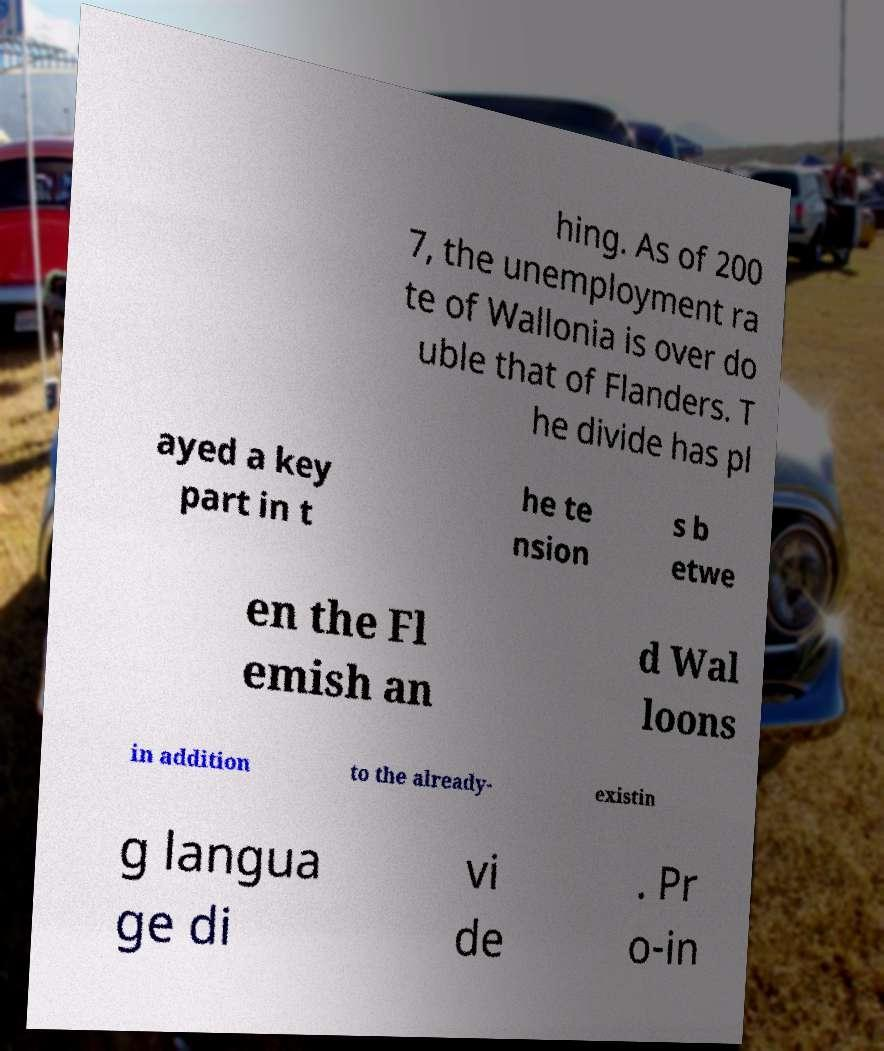Could you extract and type out the text from this image? hing. As of 200 7, the unemployment ra te of Wallonia is over do uble that of Flanders. T he divide has pl ayed a key part in t he te nsion s b etwe en the Fl emish an d Wal loons in addition to the already- existin g langua ge di vi de . Pr o-in 